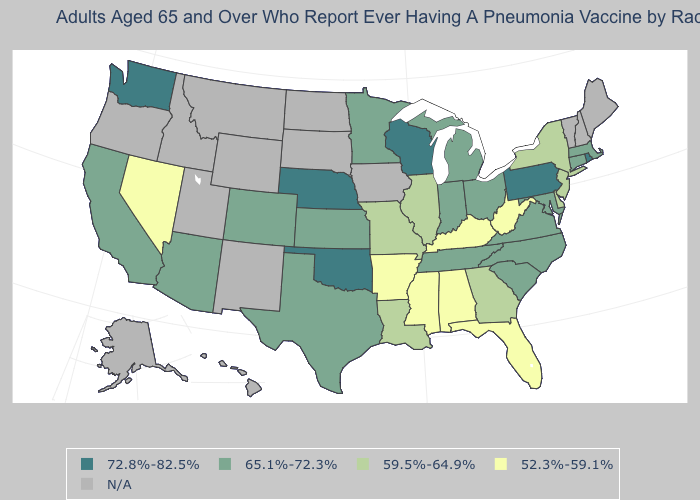What is the value of Oregon?
Quick response, please. N/A. Name the states that have a value in the range 52.3%-59.1%?
Concise answer only. Alabama, Arkansas, Florida, Kentucky, Mississippi, Nevada, West Virginia. What is the value of Vermont?
Quick response, please. N/A. Which states have the lowest value in the USA?
Quick response, please. Alabama, Arkansas, Florida, Kentucky, Mississippi, Nevada, West Virginia. What is the value of Florida?
Short answer required. 52.3%-59.1%. Which states hav the highest value in the South?
Keep it brief. Oklahoma. Does Missouri have the lowest value in the MidWest?
Answer briefly. Yes. Which states hav the highest value in the MidWest?
Keep it brief. Nebraska, Wisconsin. Is the legend a continuous bar?
Be succinct. No. Which states have the lowest value in the USA?
Be succinct. Alabama, Arkansas, Florida, Kentucky, Mississippi, Nevada, West Virginia. Name the states that have a value in the range N/A?
Be succinct. Alaska, Hawaii, Idaho, Iowa, Maine, Montana, New Hampshire, New Mexico, North Dakota, Oregon, South Dakota, Utah, Vermont, Wyoming. Name the states that have a value in the range 52.3%-59.1%?
Write a very short answer. Alabama, Arkansas, Florida, Kentucky, Mississippi, Nevada, West Virginia. What is the value of Iowa?
Give a very brief answer. N/A. 